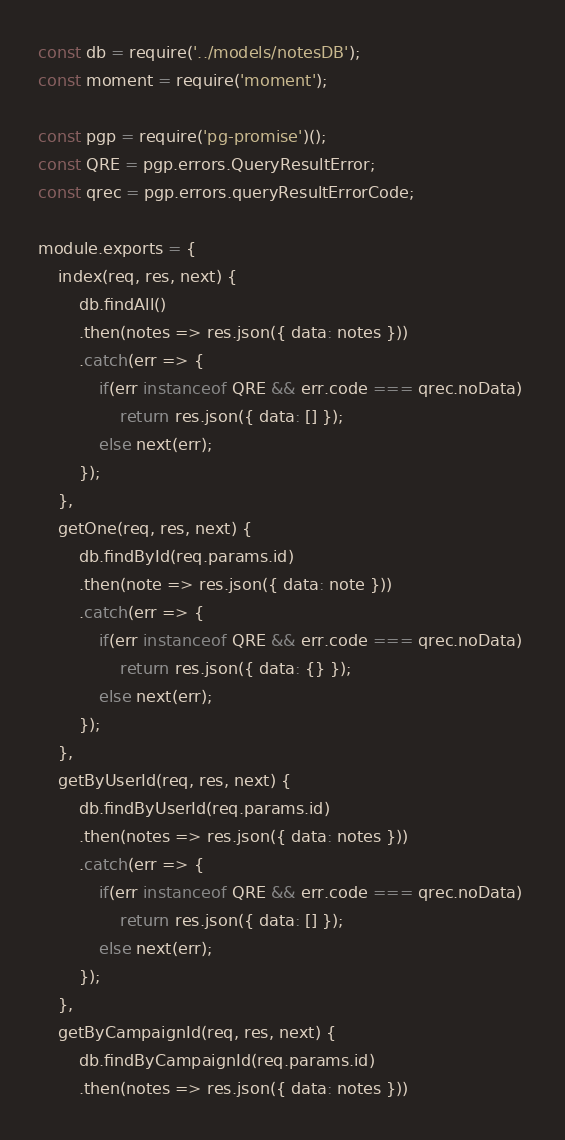Convert code to text. <code><loc_0><loc_0><loc_500><loc_500><_JavaScript_>const db = require('../models/notesDB');
const moment = require('moment');

const pgp = require('pg-promise')();
const QRE = pgp.errors.QueryResultError;
const qrec = pgp.errors.queryResultErrorCode;

module.exports = {
    index(req, res, next) {
        db.findAll()
        .then(notes => res.json({ data: notes }))
        .catch(err => {
            if(err instanceof QRE && err.code === qrec.noData) 
                return res.json({ data: [] });
            else next(err);
        });
    },
    getOne(req, res, next) {
        db.findById(req.params.id)
        .then(note => res.json({ data: note }))
        .catch(err => {
            if(err instanceof QRE && err.code === qrec.noData) 
                return res.json({ data: {} });
            else next(err);
        });
    },
    getByUserId(req, res, next) {
        db.findByUserId(req.params.id)
        .then(notes => res.json({ data: notes }))
        .catch(err => {
            if(err instanceof QRE && err.code === qrec.noData) 
                return res.json({ data: [] });
            else next(err);
        });
    },
    getByCampaignId(req, res, next) {
        db.findByCampaignId(req.params.id)
        .then(notes => res.json({ data: notes }))</code> 